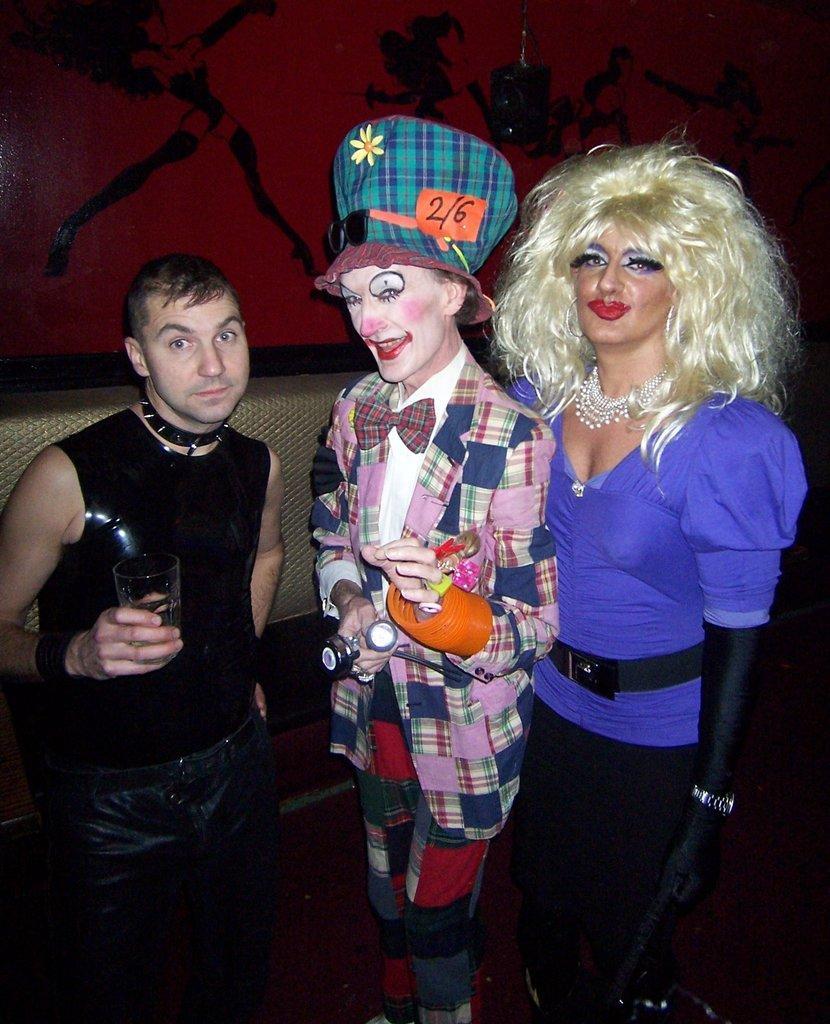How would you summarize this image in a sentence or two? In the image few people are standing and holding something in their hands. Behind them there is wall, on the wall there is painting. 